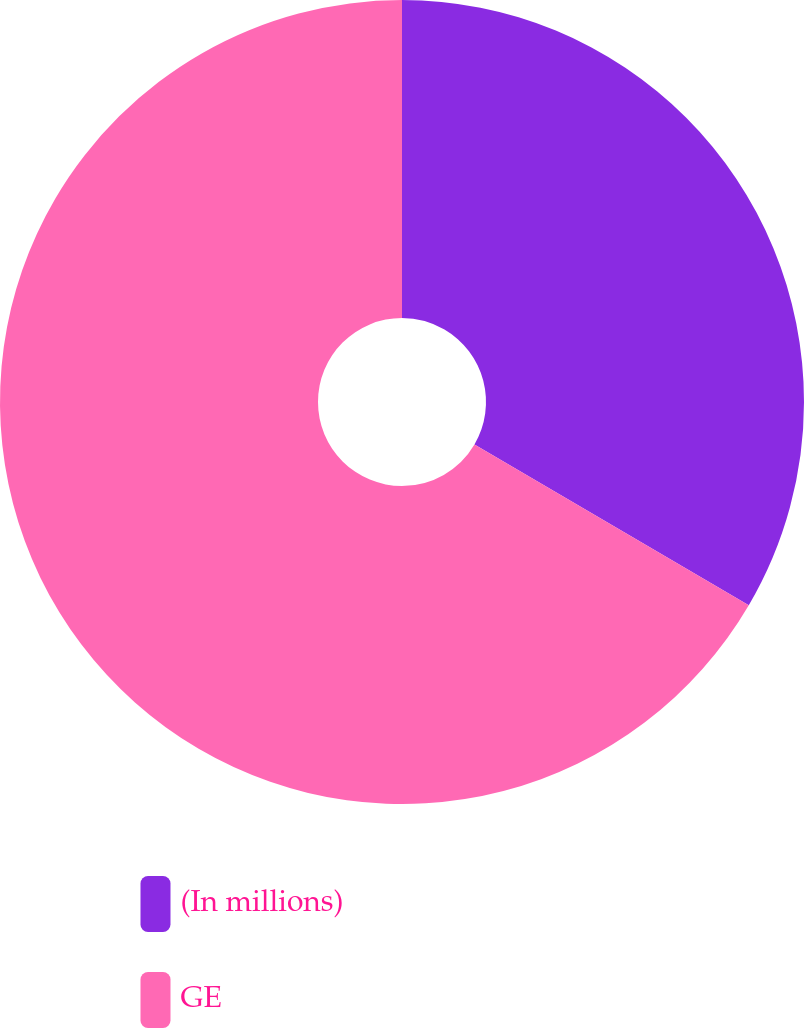<chart> <loc_0><loc_0><loc_500><loc_500><pie_chart><fcel>(In millions)<fcel>GE<nl><fcel>33.44%<fcel>66.56%<nl></chart> 